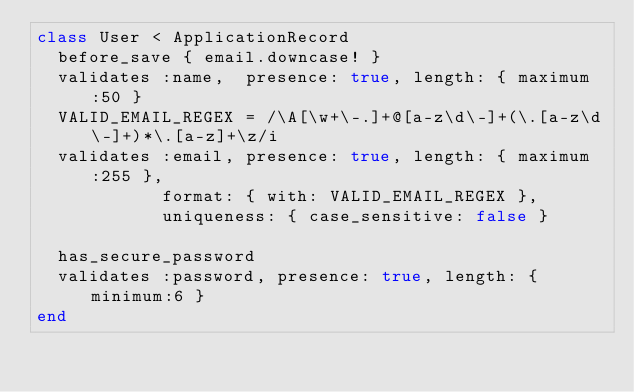<code> <loc_0><loc_0><loc_500><loc_500><_Ruby_>class User < ApplicationRecord
	before_save { email.downcase! }
	validates :name,  presence: true, length: { maximum:50 }
	VALID_EMAIL_REGEX = /\A[\w+\-.]+@[a-z\d\-]+(\.[a-z\d\-]+)*\.[a-z]+\z/i
	validates :email, presence: true, length: { maximum:255 },
					  format: { with: VALID_EMAIL_REGEX },
					  uniqueness: { case_sensitive: false }

	has_secure_password
	validates :password, presence: true, length: { minimum:6 }				  
end
</code> 